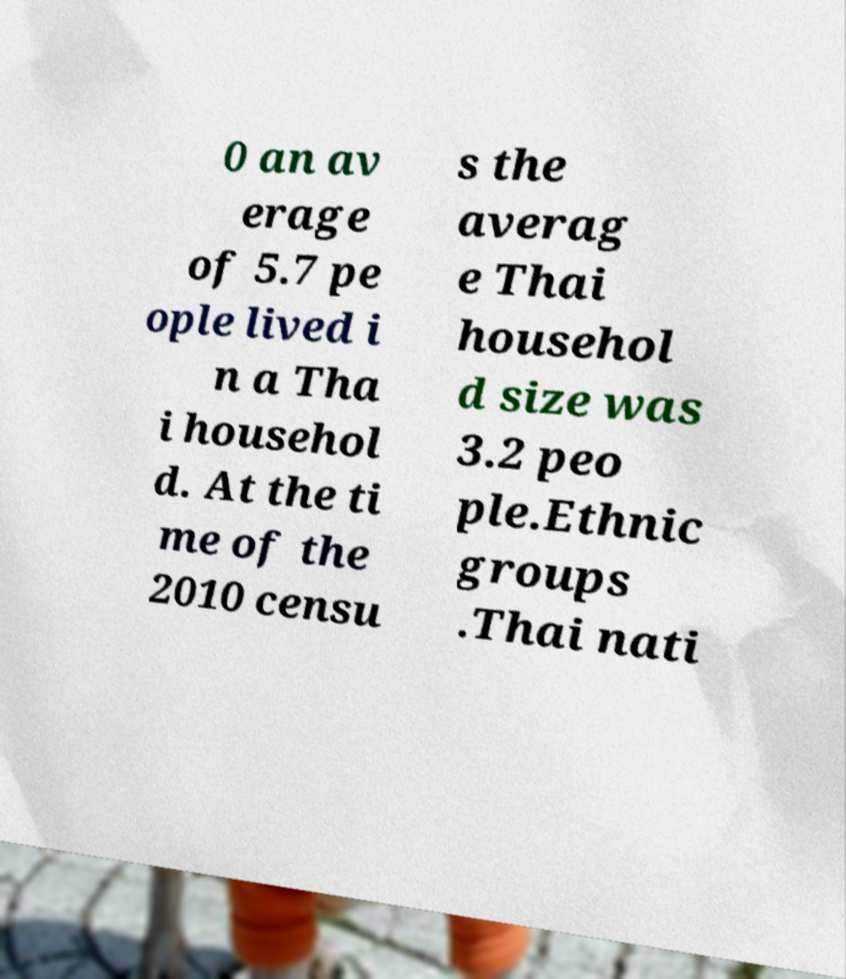Can you accurately transcribe the text from the provided image for me? 0 an av erage of 5.7 pe ople lived i n a Tha i househol d. At the ti me of the 2010 censu s the averag e Thai househol d size was 3.2 peo ple.Ethnic groups .Thai nati 